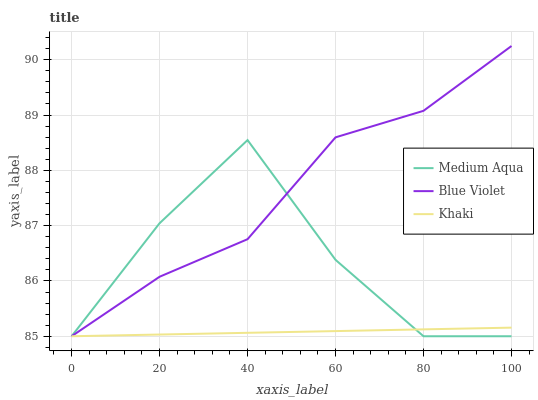Does Khaki have the minimum area under the curve?
Answer yes or no. Yes. Does Blue Violet have the maximum area under the curve?
Answer yes or no. Yes. Does Medium Aqua have the minimum area under the curve?
Answer yes or no. No. Does Medium Aqua have the maximum area under the curve?
Answer yes or no. No. Is Khaki the smoothest?
Answer yes or no. Yes. Is Medium Aqua the roughest?
Answer yes or no. Yes. Is Blue Violet the smoothest?
Answer yes or no. No. Is Blue Violet the roughest?
Answer yes or no. No. Does Khaki have the lowest value?
Answer yes or no. Yes. Does Blue Violet have the highest value?
Answer yes or no. Yes. Does Medium Aqua have the highest value?
Answer yes or no. No. Does Blue Violet intersect Khaki?
Answer yes or no. Yes. Is Blue Violet less than Khaki?
Answer yes or no. No. Is Blue Violet greater than Khaki?
Answer yes or no. No. 